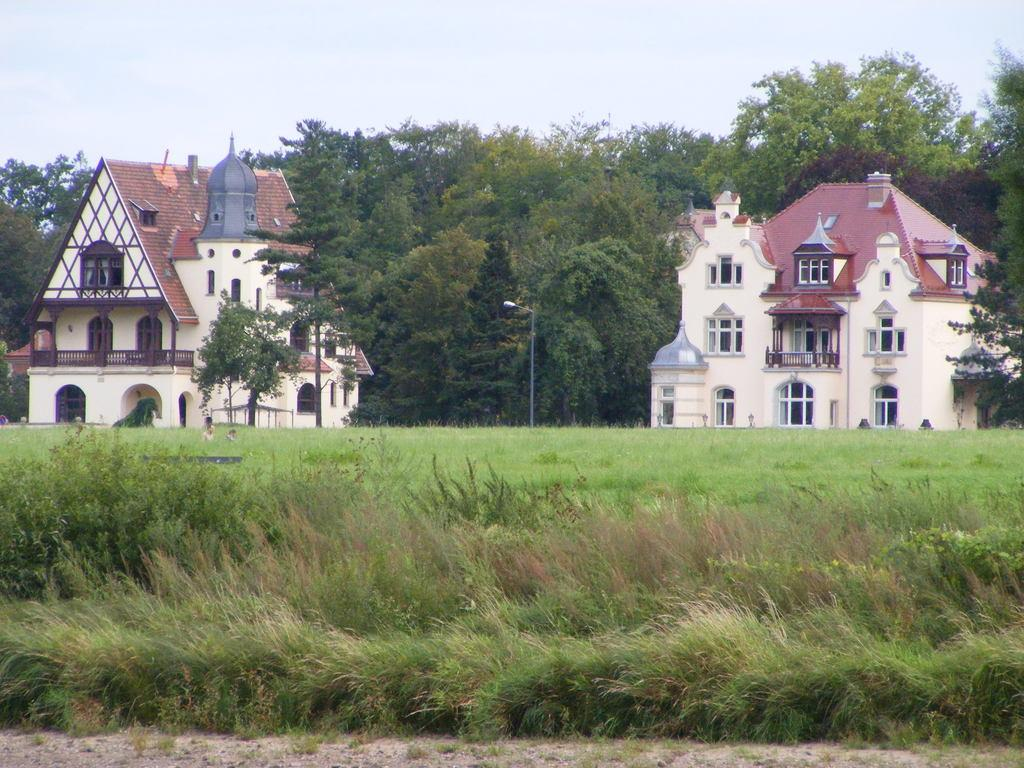What type of vegetation can be seen in the image? There is grass in the image. What structures are visible in the background of the image? There are buildings with windows in the background of the image. What other natural elements can be seen in the background of the image? There are many trees in the background of the image. What part of the natural environment is visible in the background of the image? The sky is visible in the background of the image. What direction is the grass growing in the image? Grass does not grow in a specific direction; it grows outward from its base. 